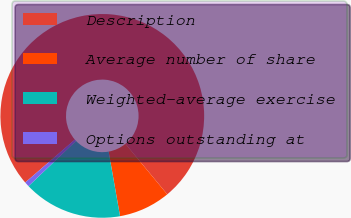Convert chart. <chart><loc_0><loc_0><loc_500><loc_500><pie_chart><fcel>Description<fcel>Average number of share<fcel>Weighted-average exercise<fcel>Options outstanding at<nl><fcel>75.34%<fcel>8.22%<fcel>15.68%<fcel>0.76%<nl></chart> 